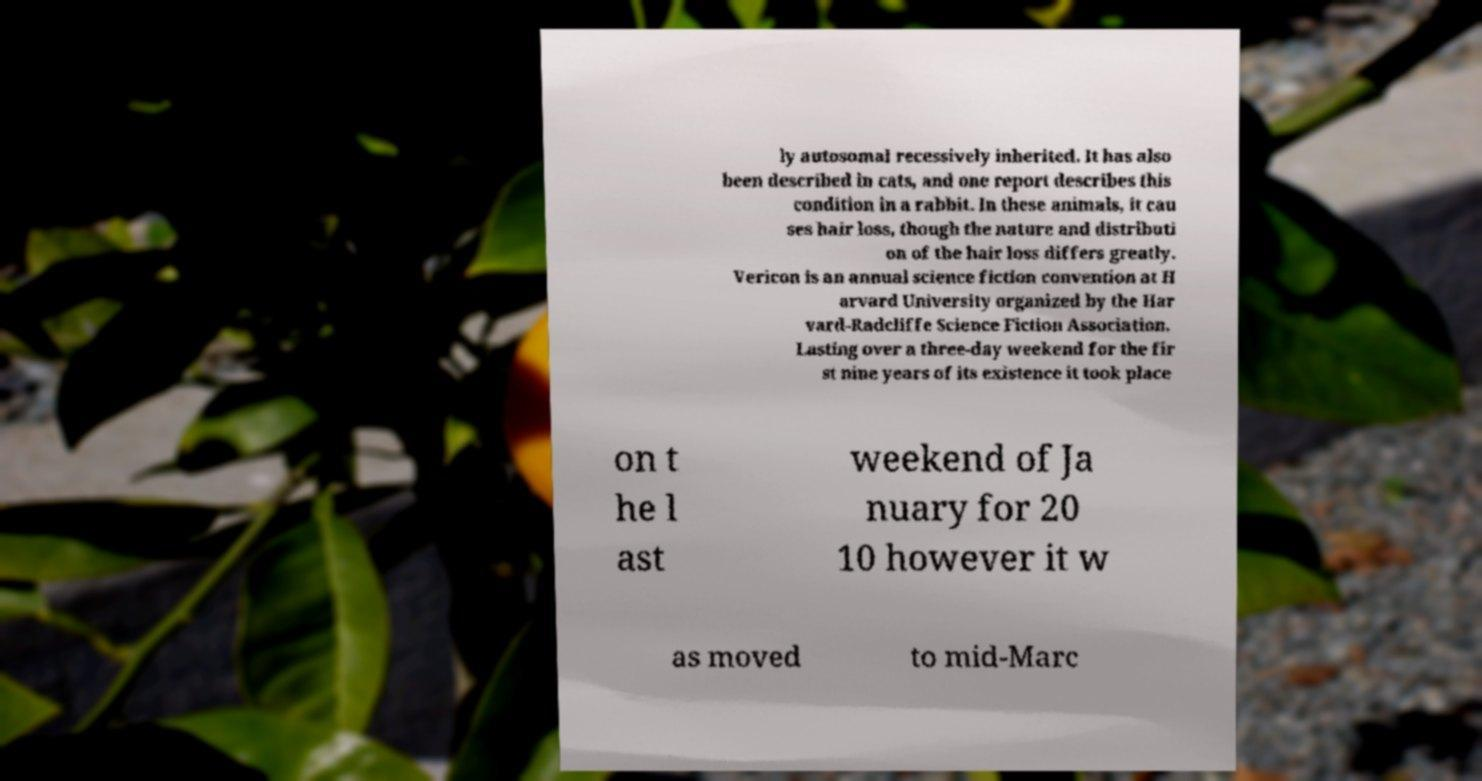Could you extract and type out the text from this image? ly autosomal recessively inherited. It has also been described in cats, and one report describes this condition in a rabbit. In these animals, it cau ses hair loss, though the nature and distributi on of the hair loss differs greatly. Vericon is an annual science fiction convention at H arvard University organized by the Har vard-Radcliffe Science Fiction Association. Lasting over a three-day weekend for the fir st nine years of its existence it took place on t he l ast weekend of Ja nuary for 20 10 however it w as moved to mid-Marc 